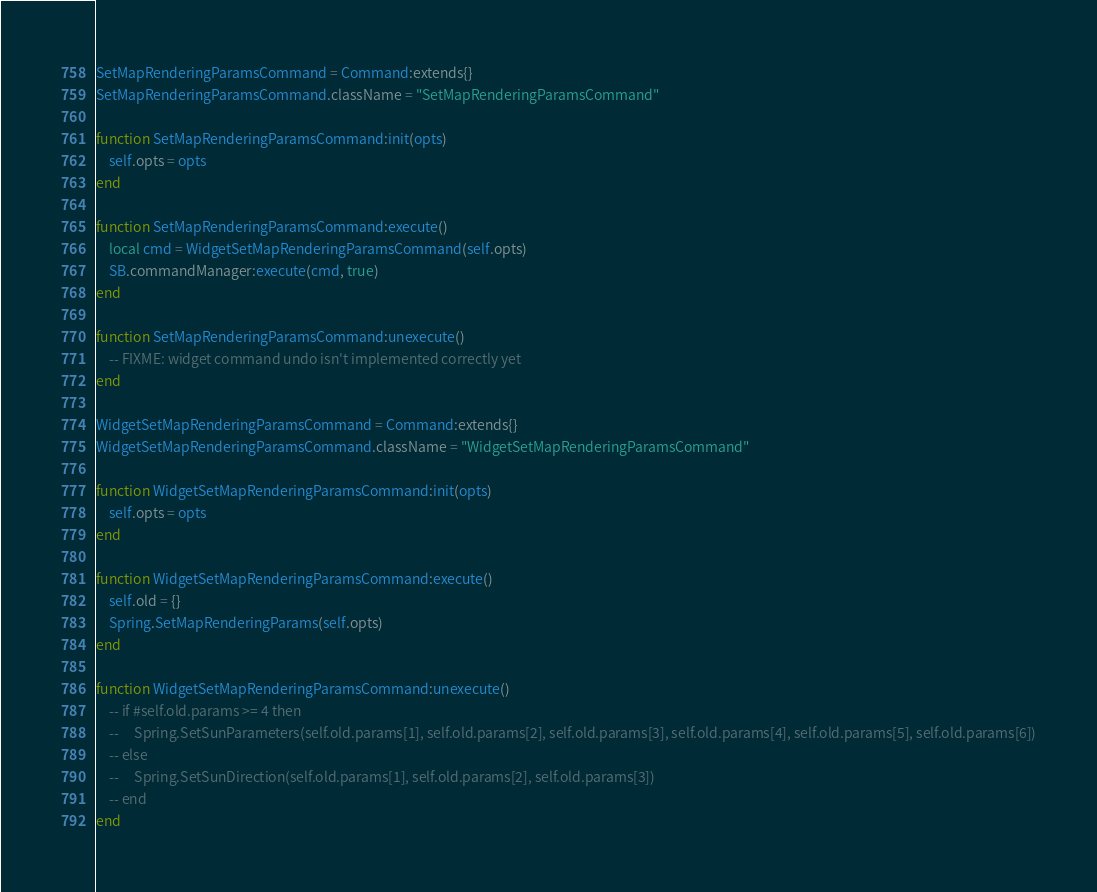Convert code to text. <code><loc_0><loc_0><loc_500><loc_500><_Lua_>SetMapRenderingParamsCommand = Command:extends{}
SetMapRenderingParamsCommand.className = "SetMapRenderingParamsCommand"

function SetMapRenderingParamsCommand:init(opts)
    self.opts = opts
end

function SetMapRenderingParamsCommand:execute()
    local cmd = WidgetSetMapRenderingParamsCommand(self.opts)
    SB.commandManager:execute(cmd, true)
end

function SetMapRenderingParamsCommand:unexecute()
    -- FIXME: widget command undo isn't implemented correctly yet
end

WidgetSetMapRenderingParamsCommand = Command:extends{}
WidgetSetMapRenderingParamsCommand.className = "WidgetSetMapRenderingParamsCommand"

function WidgetSetMapRenderingParamsCommand:init(opts)
    self.opts = opts
end

function WidgetSetMapRenderingParamsCommand:execute()
    self.old = {}
    Spring.SetMapRenderingParams(self.opts)
end

function WidgetSetMapRenderingParamsCommand:unexecute()
    -- if #self.old.params >= 4 then
    --     Spring.SetSunParameters(self.old.params[1], self.old.params[2], self.old.params[3], self.old.params[4], self.old.params[5], self.old.params[6])
    -- else
    --     Spring.SetSunDirection(self.old.params[1], self.old.params[2], self.old.params[3])
    -- end
end
</code> 